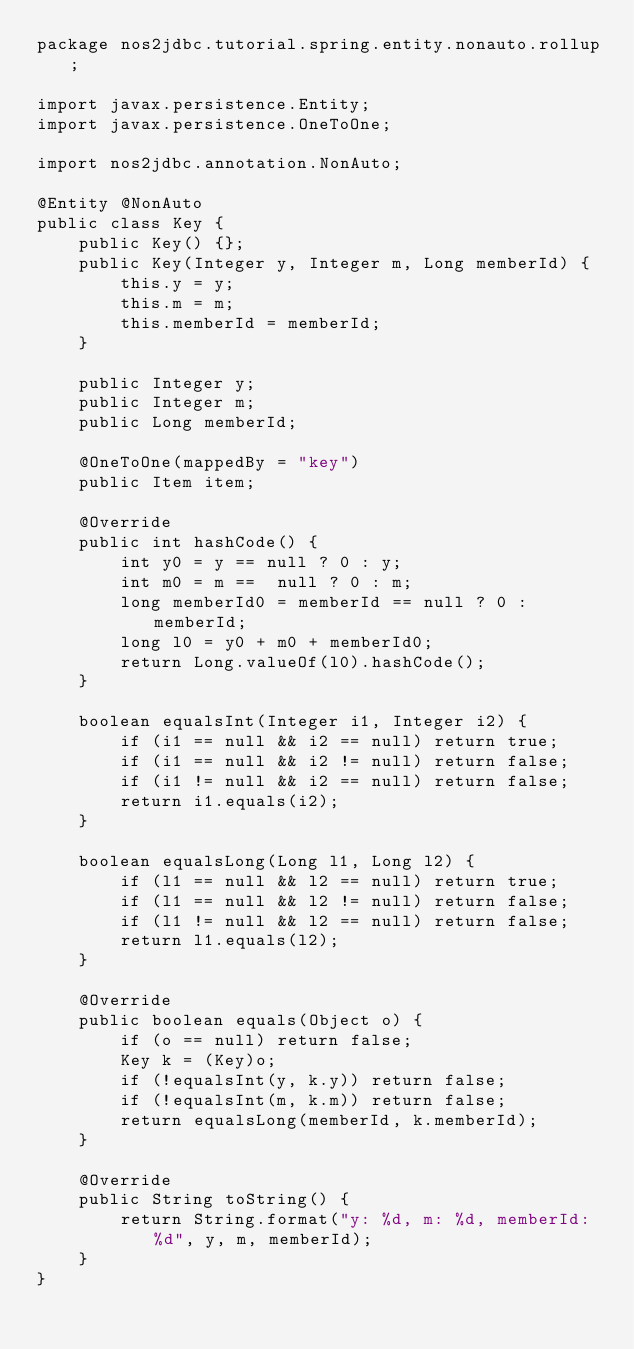<code> <loc_0><loc_0><loc_500><loc_500><_Java_>package nos2jdbc.tutorial.spring.entity.nonauto.rollup;

import javax.persistence.Entity;
import javax.persistence.OneToOne;

import nos2jdbc.annotation.NonAuto;

@Entity @NonAuto
public class Key {
    public Key() {};
    public Key(Integer y, Integer m, Long memberId) {
        this.y = y;
        this.m = m;
        this.memberId = memberId;
    }
    
    public Integer y;
    public Integer m;
    public Long memberId;

    @OneToOne(mappedBy = "key")
    public Item item;

    @Override
    public int hashCode() {
        int y0 = y == null ? 0 : y;
        int m0 = m ==  null ? 0 : m;
        long memberId0 = memberId == null ? 0 : memberId;
        long l0 = y0 + m0 + memberId0;
        return Long.valueOf(l0).hashCode();
    }

    boolean equalsInt(Integer i1, Integer i2) {
        if (i1 == null && i2 == null) return true;
        if (i1 == null && i2 != null) return false;
        if (i1 != null && i2 == null) return false;
        return i1.equals(i2);
    }

    boolean equalsLong(Long l1, Long l2) {
        if (l1 == null && l2 == null) return true;
        if (l1 == null && l2 != null) return false;
        if (l1 != null && l2 == null) return false;
        return l1.equals(l2);
    }

    @Override
    public boolean equals(Object o) {
        if (o == null) return false;
        Key k = (Key)o;
        if (!equalsInt(y, k.y)) return false;
        if (!equalsInt(m, k.m)) return false;
        return equalsLong(memberId, k.memberId);
    }
    
    @Override
    public String toString() {
        return String.format("y: %d, m: %d, memberId: %d", y, m, memberId);
    }
}
</code> 